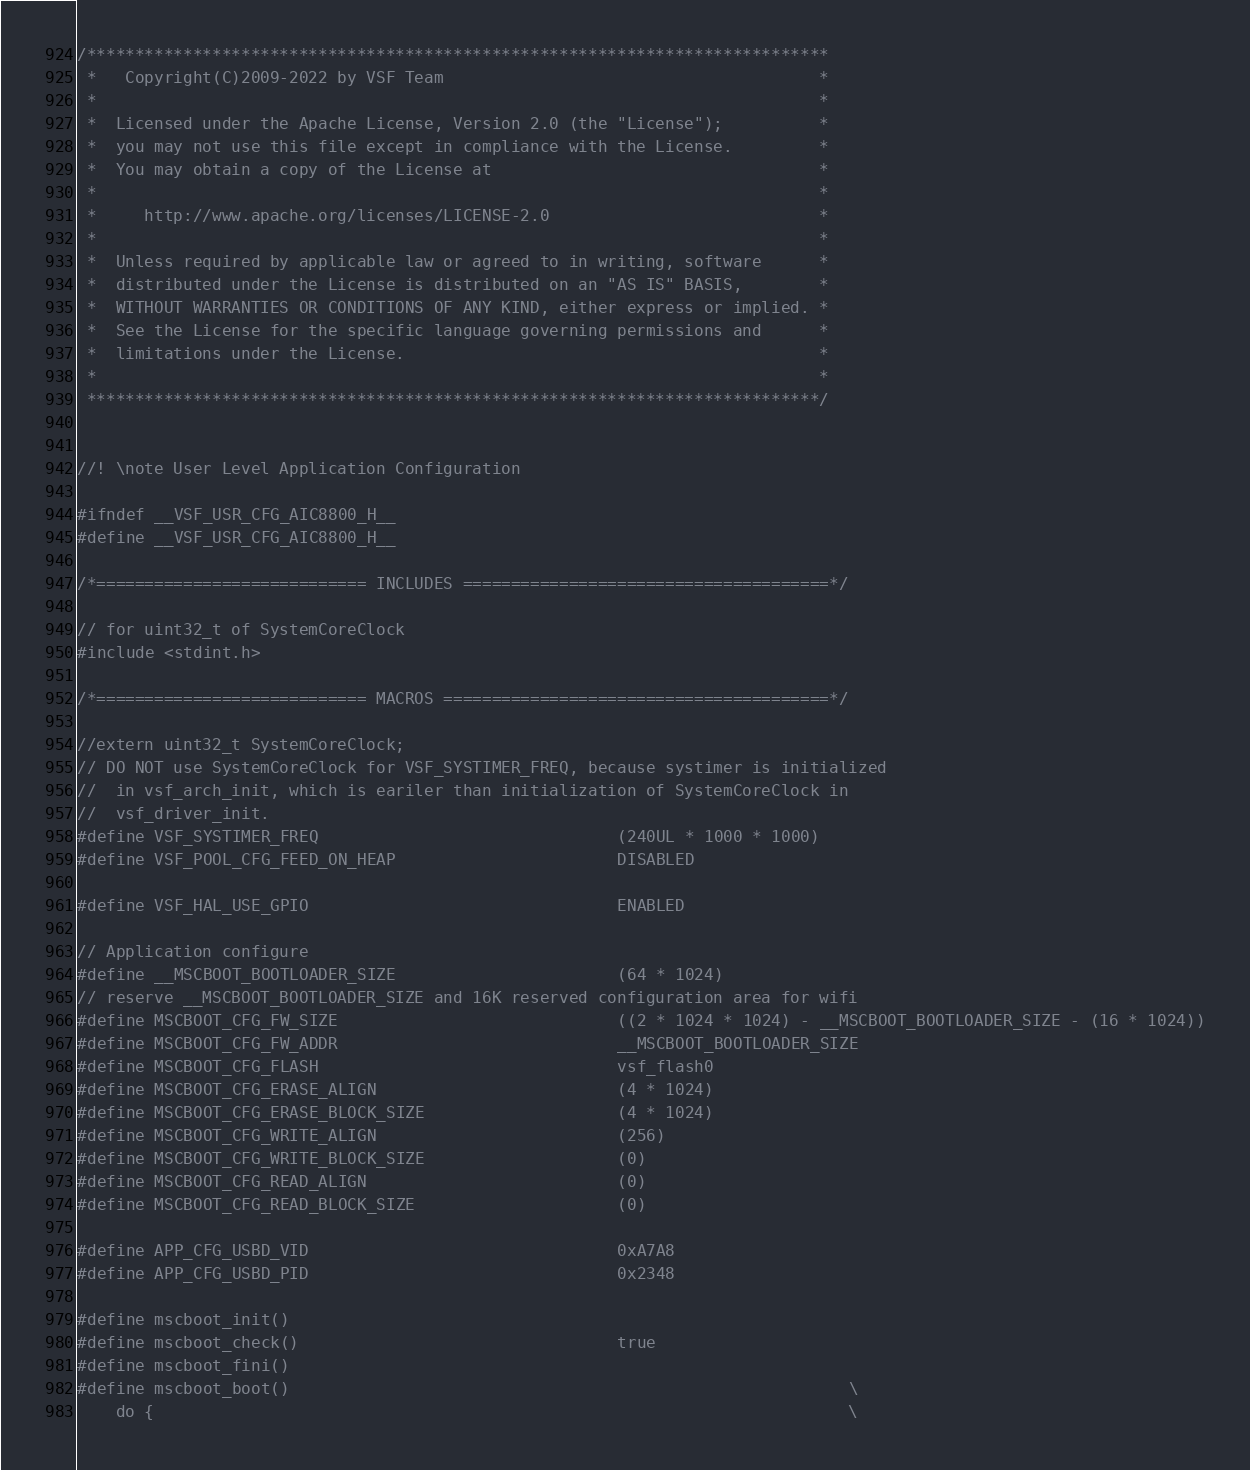Convert code to text. <code><loc_0><loc_0><loc_500><loc_500><_C_>/*****************************************************************************
 *   Copyright(C)2009-2022 by VSF Team                                       *
 *                                                                           *
 *  Licensed under the Apache License, Version 2.0 (the "License");          *
 *  you may not use this file except in compliance with the License.         *
 *  You may obtain a copy of the License at                                  *
 *                                                                           *
 *     http://www.apache.org/licenses/LICENSE-2.0                            *
 *                                                                           *
 *  Unless required by applicable law or agreed to in writing, software      *
 *  distributed under the License is distributed on an "AS IS" BASIS,        *
 *  WITHOUT WARRANTIES OR CONDITIONS OF ANY KIND, either express or implied. *
 *  See the License for the specific language governing permissions and      *
 *  limitations under the License.                                           *
 *                                                                           *
 ****************************************************************************/


//! \note User Level Application Configuration

#ifndef __VSF_USR_CFG_AIC8800_H__
#define __VSF_USR_CFG_AIC8800_H__

/*============================ INCLUDES ======================================*/

// for uint32_t of SystemCoreClock
#include <stdint.h>

/*============================ MACROS ========================================*/

//extern uint32_t SystemCoreClock;
// DO NOT use SystemCoreClock for VSF_SYSTIMER_FREQ, because systimer is initialized
//  in vsf_arch_init, which is eariler than initialization of SystemCoreClock in
//  vsf_driver_init.
#define VSF_SYSTIMER_FREQ                               (240UL * 1000 * 1000)
#define VSF_POOL_CFG_FEED_ON_HEAP                       DISABLED

#define VSF_HAL_USE_GPIO                                ENABLED

// Application configure
#define __MSCBOOT_BOOTLOADER_SIZE                       (64 * 1024)
// reserve __MSCBOOT_BOOTLOADER_SIZE and 16K reserved configuration area for wifi
#define MSCBOOT_CFG_FW_SIZE                             ((2 * 1024 * 1024) - __MSCBOOT_BOOTLOADER_SIZE - (16 * 1024))
#define MSCBOOT_CFG_FW_ADDR                             __MSCBOOT_BOOTLOADER_SIZE
#define MSCBOOT_CFG_FLASH                               vsf_flash0
#define MSCBOOT_CFG_ERASE_ALIGN                         (4 * 1024)
#define MSCBOOT_CFG_ERASE_BLOCK_SIZE                    (4 * 1024)
#define MSCBOOT_CFG_WRITE_ALIGN                         (256)
#define MSCBOOT_CFG_WRITE_BLOCK_SIZE                    (0)
#define MSCBOOT_CFG_READ_ALIGN                          (0)
#define MSCBOOT_CFG_READ_BLOCK_SIZE                     (0)

#define APP_CFG_USBD_VID                                0xA7A8
#define APP_CFG_USBD_PID                                0x2348

#define mscboot_init()
#define mscboot_check()                                 true
#define mscboot_fini()
#define mscboot_boot()                                                          \
    do {                                                                        \</code> 